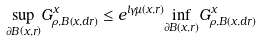<formula> <loc_0><loc_0><loc_500><loc_500>\underset { \partial B \left ( x , r \right ) } { \sup } G _ { \rho , B \left ( x , d r \right ) } ^ { x } \leq e ^ { l \gamma \mu \left ( x , r \right ) } \underset { \partial B \left ( x , r \right ) } { \inf } G _ { \rho , B \left ( x , d r \right ) } ^ { x }</formula> 